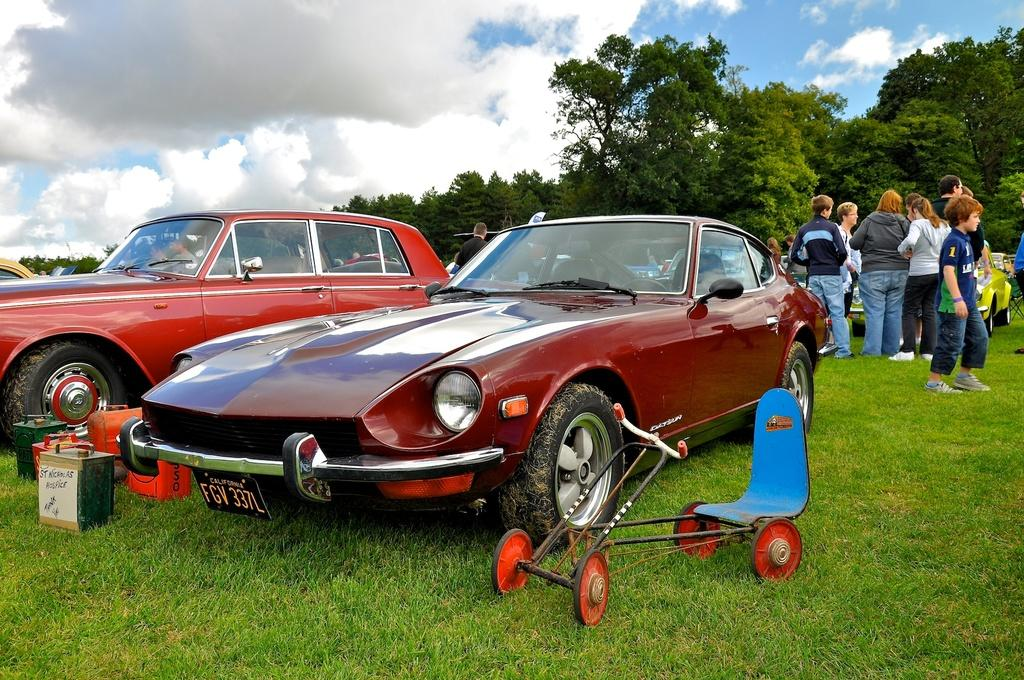What can be seen on the right side of the image? There are people standing on the right side of the image. What is located in the middle of the image? There are many trees in the middle of the image. What type of vehicle is on the left side of the image? There is a red car on the left side of the image. Can you see any mice nesting in the red car in the image? There are no mice or nests present in the image, and the focus is on the people, trees, and red car. 